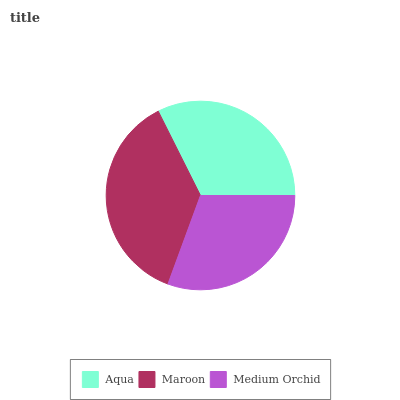Is Medium Orchid the minimum?
Answer yes or no. Yes. Is Maroon the maximum?
Answer yes or no. Yes. Is Maroon the minimum?
Answer yes or no. No. Is Medium Orchid the maximum?
Answer yes or no. No. Is Maroon greater than Medium Orchid?
Answer yes or no. Yes. Is Medium Orchid less than Maroon?
Answer yes or no. Yes. Is Medium Orchid greater than Maroon?
Answer yes or no. No. Is Maroon less than Medium Orchid?
Answer yes or no. No. Is Aqua the high median?
Answer yes or no. Yes. Is Aqua the low median?
Answer yes or no. Yes. Is Medium Orchid the high median?
Answer yes or no. No. Is Maroon the low median?
Answer yes or no. No. 